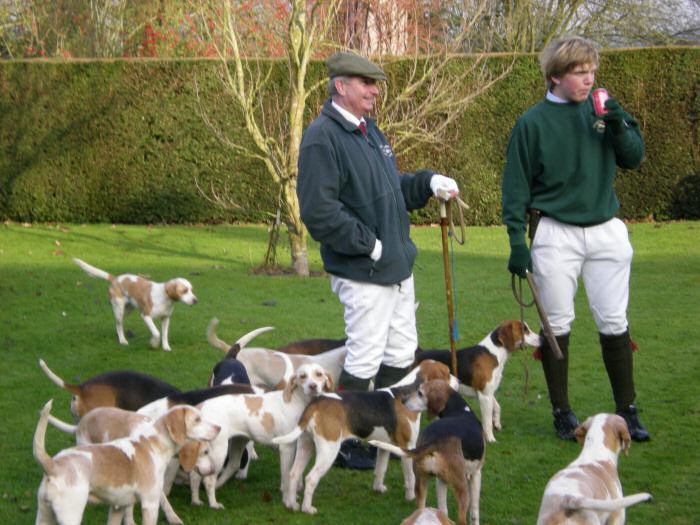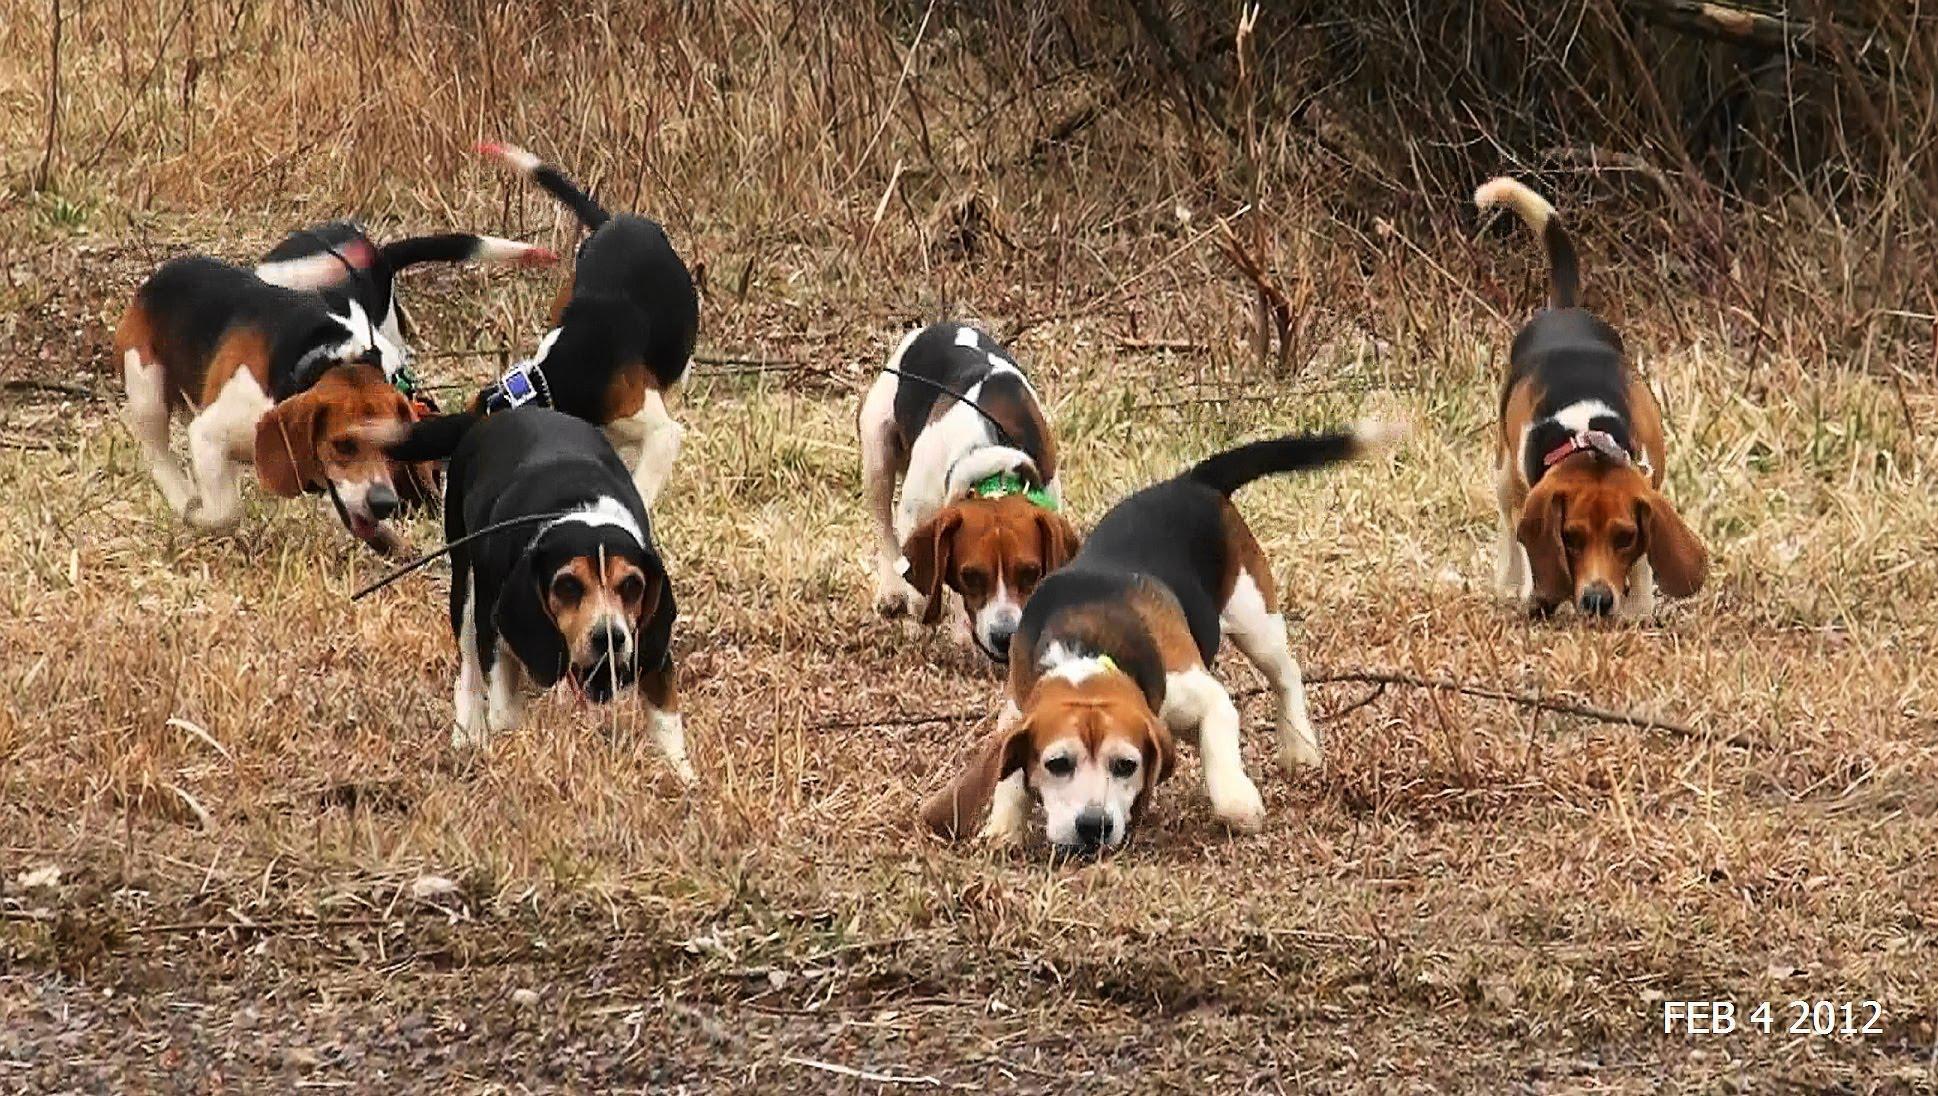The first image is the image on the left, the second image is the image on the right. Examine the images to the left and right. Is the description "One image has no more than one dog." accurate? Answer yes or no. No. The first image is the image on the left, the second image is the image on the right. For the images displayed, is the sentence "in at least one photo a man is using a walking stick on the grass" factually correct? Answer yes or no. Yes. 